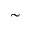<formula> <loc_0><loc_0><loc_500><loc_500>\sim</formula> 